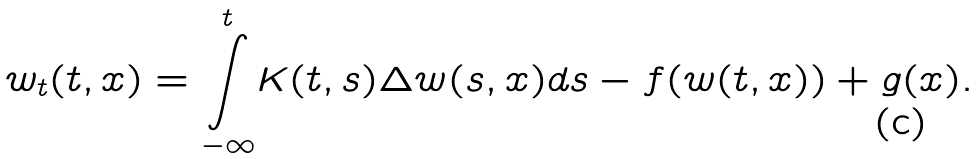Convert formula to latex. <formula><loc_0><loc_0><loc_500><loc_500>w _ { t } ( t , x ) = \overset { t } { \underset { - \infty } { \int } } K ( t , s ) \Delta w ( s , x ) d s - f ( w ( t , x ) ) + g ( x ) .</formula> 